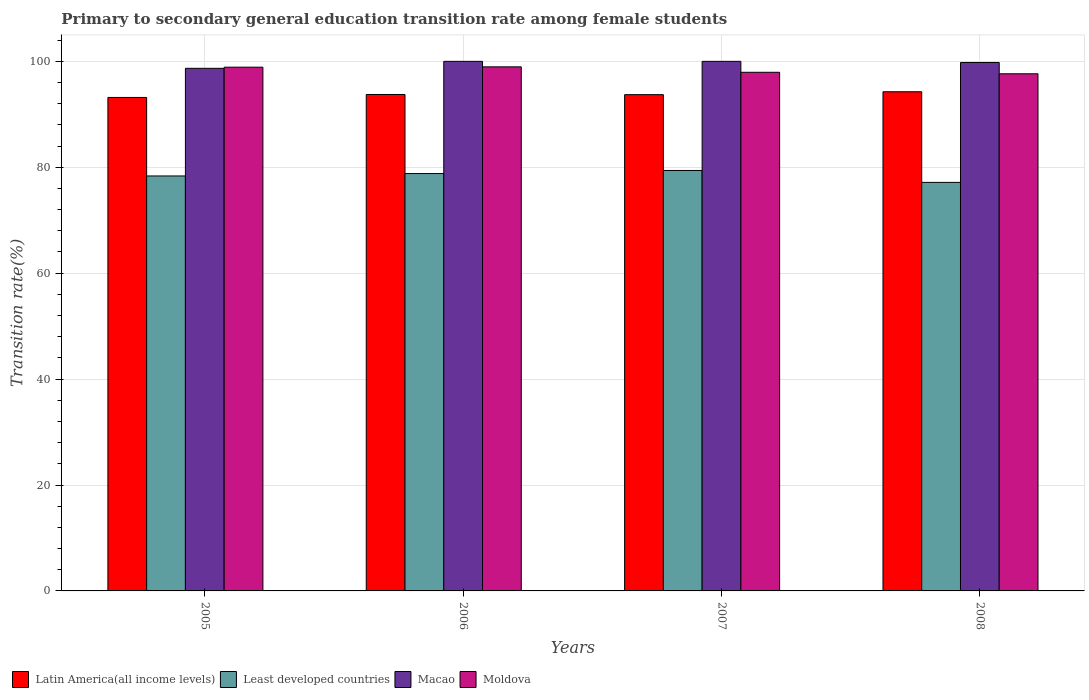Are the number of bars on each tick of the X-axis equal?
Offer a terse response. Yes. How many bars are there on the 1st tick from the left?
Provide a succinct answer. 4. How many bars are there on the 4th tick from the right?
Your answer should be very brief. 4. What is the transition rate in Latin America(all income levels) in 2005?
Provide a short and direct response. 93.18. Across all years, what is the minimum transition rate in Latin America(all income levels)?
Provide a short and direct response. 93.18. What is the total transition rate in Macao in the graph?
Your answer should be very brief. 398.47. What is the difference between the transition rate in Macao in 2006 and that in 2008?
Your response must be concise. 0.21. What is the difference between the transition rate in Least developed countries in 2007 and the transition rate in Moldova in 2008?
Offer a very short reply. -18.26. What is the average transition rate in Macao per year?
Your answer should be compact. 99.62. In the year 2006, what is the difference between the transition rate in Latin America(all income levels) and transition rate in Least developed countries?
Make the answer very short. 14.93. What is the ratio of the transition rate in Least developed countries in 2005 to that in 2007?
Give a very brief answer. 0.99. Is the difference between the transition rate in Latin America(all income levels) in 2005 and 2006 greater than the difference between the transition rate in Least developed countries in 2005 and 2006?
Make the answer very short. No. What is the difference between the highest and the second highest transition rate in Latin America(all income levels)?
Provide a short and direct response. 0.51. What is the difference between the highest and the lowest transition rate in Moldova?
Keep it short and to the point. 1.31. In how many years, is the transition rate in Latin America(all income levels) greater than the average transition rate in Latin America(all income levels) taken over all years?
Make the answer very short. 2. Is the sum of the transition rate in Moldova in 2005 and 2007 greater than the maximum transition rate in Macao across all years?
Provide a short and direct response. Yes. Is it the case that in every year, the sum of the transition rate in Latin America(all income levels) and transition rate in Least developed countries is greater than the sum of transition rate in Moldova and transition rate in Macao?
Offer a very short reply. Yes. What does the 1st bar from the left in 2006 represents?
Ensure brevity in your answer.  Latin America(all income levels). What does the 2nd bar from the right in 2005 represents?
Ensure brevity in your answer.  Macao. Are all the bars in the graph horizontal?
Your answer should be very brief. No. Are the values on the major ticks of Y-axis written in scientific E-notation?
Keep it short and to the point. No. Does the graph contain any zero values?
Keep it short and to the point. No. Does the graph contain grids?
Keep it short and to the point. Yes. What is the title of the graph?
Give a very brief answer. Primary to secondary general education transition rate among female students. What is the label or title of the X-axis?
Your response must be concise. Years. What is the label or title of the Y-axis?
Ensure brevity in your answer.  Transition rate(%). What is the Transition rate(%) of Latin America(all income levels) in 2005?
Your response must be concise. 93.18. What is the Transition rate(%) in Least developed countries in 2005?
Give a very brief answer. 78.36. What is the Transition rate(%) in Macao in 2005?
Provide a short and direct response. 98.68. What is the Transition rate(%) in Moldova in 2005?
Offer a very short reply. 98.9. What is the Transition rate(%) of Latin America(all income levels) in 2006?
Your answer should be compact. 93.74. What is the Transition rate(%) of Least developed countries in 2006?
Offer a terse response. 78.81. What is the Transition rate(%) of Moldova in 2006?
Offer a very short reply. 98.96. What is the Transition rate(%) of Latin America(all income levels) in 2007?
Your answer should be very brief. 93.71. What is the Transition rate(%) in Least developed countries in 2007?
Keep it short and to the point. 79.39. What is the Transition rate(%) in Macao in 2007?
Offer a very short reply. 100. What is the Transition rate(%) of Moldova in 2007?
Ensure brevity in your answer.  97.93. What is the Transition rate(%) of Latin America(all income levels) in 2008?
Keep it short and to the point. 94.26. What is the Transition rate(%) of Least developed countries in 2008?
Your answer should be compact. 77.15. What is the Transition rate(%) of Macao in 2008?
Offer a very short reply. 99.79. What is the Transition rate(%) of Moldova in 2008?
Offer a terse response. 97.65. Across all years, what is the maximum Transition rate(%) in Latin America(all income levels)?
Make the answer very short. 94.26. Across all years, what is the maximum Transition rate(%) of Least developed countries?
Your answer should be compact. 79.39. Across all years, what is the maximum Transition rate(%) in Moldova?
Make the answer very short. 98.96. Across all years, what is the minimum Transition rate(%) of Latin America(all income levels)?
Your answer should be very brief. 93.18. Across all years, what is the minimum Transition rate(%) of Least developed countries?
Offer a very short reply. 77.15. Across all years, what is the minimum Transition rate(%) of Macao?
Offer a very short reply. 98.68. Across all years, what is the minimum Transition rate(%) in Moldova?
Make the answer very short. 97.65. What is the total Transition rate(%) of Latin America(all income levels) in the graph?
Keep it short and to the point. 374.9. What is the total Transition rate(%) in Least developed countries in the graph?
Provide a short and direct response. 313.71. What is the total Transition rate(%) in Macao in the graph?
Offer a very short reply. 398.47. What is the total Transition rate(%) in Moldova in the graph?
Provide a succinct answer. 393.45. What is the difference between the Transition rate(%) in Latin America(all income levels) in 2005 and that in 2006?
Provide a succinct answer. -0.56. What is the difference between the Transition rate(%) in Least developed countries in 2005 and that in 2006?
Make the answer very short. -0.46. What is the difference between the Transition rate(%) of Macao in 2005 and that in 2006?
Your response must be concise. -1.32. What is the difference between the Transition rate(%) of Moldova in 2005 and that in 2006?
Give a very brief answer. -0.06. What is the difference between the Transition rate(%) in Latin America(all income levels) in 2005 and that in 2007?
Provide a short and direct response. -0.53. What is the difference between the Transition rate(%) of Least developed countries in 2005 and that in 2007?
Ensure brevity in your answer.  -1.04. What is the difference between the Transition rate(%) in Macao in 2005 and that in 2007?
Ensure brevity in your answer.  -1.32. What is the difference between the Transition rate(%) of Moldova in 2005 and that in 2007?
Provide a short and direct response. 0.96. What is the difference between the Transition rate(%) of Latin America(all income levels) in 2005 and that in 2008?
Make the answer very short. -1.07. What is the difference between the Transition rate(%) in Least developed countries in 2005 and that in 2008?
Provide a succinct answer. 1.21. What is the difference between the Transition rate(%) in Macao in 2005 and that in 2008?
Provide a short and direct response. -1.1. What is the difference between the Transition rate(%) of Moldova in 2005 and that in 2008?
Provide a short and direct response. 1.25. What is the difference between the Transition rate(%) in Latin America(all income levels) in 2006 and that in 2007?
Ensure brevity in your answer.  0.03. What is the difference between the Transition rate(%) of Least developed countries in 2006 and that in 2007?
Give a very brief answer. -0.58. What is the difference between the Transition rate(%) in Macao in 2006 and that in 2007?
Your response must be concise. 0. What is the difference between the Transition rate(%) in Latin America(all income levels) in 2006 and that in 2008?
Your answer should be compact. -0.51. What is the difference between the Transition rate(%) in Least developed countries in 2006 and that in 2008?
Make the answer very short. 1.67. What is the difference between the Transition rate(%) of Macao in 2006 and that in 2008?
Provide a short and direct response. 0.21. What is the difference between the Transition rate(%) in Moldova in 2006 and that in 2008?
Make the answer very short. 1.31. What is the difference between the Transition rate(%) in Latin America(all income levels) in 2007 and that in 2008?
Provide a short and direct response. -0.54. What is the difference between the Transition rate(%) of Least developed countries in 2007 and that in 2008?
Ensure brevity in your answer.  2.25. What is the difference between the Transition rate(%) of Macao in 2007 and that in 2008?
Your response must be concise. 0.21. What is the difference between the Transition rate(%) of Moldova in 2007 and that in 2008?
Your answer should be very brief. 0.28. What is the difference between the Transition rate(%) in Latin America(all income levels) in 2005 and the Transition rate(%) in Least developed countries in 2006?
Make the answer very short. 14.37. What is the difference between the Transition rate(%) of Latin America(all income levels) in 2005 and the Transition rate(%) of Macao in 2006?
Ensure brevity in your answer.  -6.82. What is the difference between the Transition rate(%) of Latin America(all income levels) in 2005 and the Transition rate(%) of Moldova in 2006?
Offer a terse response. -5.78. What is the difference between the Transition rate(%) in Least developed countries in 2005 and the Transition rate(%) in Macao in 2006?
Make the answer very short. -21.64. What is the difference between the Transition rate(%) in Least developed countries in 2005 and the Transition rate(%) in Moldova in 2006?
Your response must be concise. -20.6. What is the difference between the Transition rate(%) in Macao in 2005 and the Transition rate(%) in Moldova in 2006?
Provide a succinct answer. -0.28. What is the difference between the Transition rate(%) in Latin America(all income levels) in 2005 and the Transition rate(%) in Least developed countries in 2007?
Give a very brief answer. 13.79. What is the difference between the Transition rate(%) of Latin America(all income levels) in 2005 and the Transition rate(%) of Macao in 2007?
Ensure brevity in your answer.  -6.82. What is the difference between the Transition rate(%) in Latin America(all income levels) in 2005 and the Transition rate(%) in Moldova in 2007?
Ensure brevity in your answer.  -4.75. What is the difference between the Transition rate(%) in Least developed countries in 2005 and the Transition rate(%) in Macao in 2007?
Your answer should be very brief. -21.64. What is the difference between the Transition rate(%) of Least developed countries in 2005 and the Transition rate(%) of Moldova in 2007?
Ensure brevity in your answer.  -19.58. What is the difference between the Transition rate(%) of Macao in 2005 and the Transition rate(%) of Moldova in 2007?
Your response must be concise. 0.75. What is the difference between the Transition rate(%) in Latin America(all income levels) in 2005 and the Transition rate(%) in Least developed countries in 2008?
Ensure brevity in your answer.  16.04. What is the difference between the Transition rate(%) in Latin America(all income levels) in 2005 and the Transition rate(%) in Macao in 2008?
Your answer should be compact. -6.6. What is the difference between the Transition rate(%) in Latin America(all income levels) in 2005 and the Transition rate(%) in Moldova in 2008?
Keep it short and to the point. -4.47. What is the difference between the Transition rate(%) of Least developed countries in 2005 and the Transition rate(%) of Macao in 2008?
Give a very brief answer. -21.43. What is the difference between the Transition rate(%) of Least developed countries in 2005 and the Transition rate(%) of Moldova in 2008?
Ensure brevity in your answer.  -19.29. What is the difference between the Transition rate(%) of Macao in 2005 and the Transition rate(%) of Moldova in 2008?
Give a very brief answer. 1.03. What is the difference between the Transition rate(%) in Latin America(all income levels) in 2006 and the Transition rate(%) in Least developed countries in 2007?
Your answer should be compact. 14.35. What is the difference between the Transition rate(%) in Latin America(all income levels) in 2006 and the Transition rate(%) in Macao in 2007?
Offer a very short reply. -6.26. What is the difference between the Transition rate(%) in Latin America(all income levels) in 2006 and the Transition rate(%) in Moldova in 2007?
Ensure brevity in your answer.  -4.19. What is the difference between the Transition rate(%) of Least developed countries in 2006 and the Transition rate(%) of Macao in 2007?
Provide a succinct answer. -21.19. What is the difference between the Transition rate(%) of Least developed countries in 2006 and the Transition rate(%) of Moldova in 2007?
Provide a succinct answer. -19.12. What is the difference between the Transition rate(%) in Macao in 2006 and the Transition rate(%) in Moldova in 2007?
Your answer should be very brief. 2.07. What is the difference between the Transition rate(%) of Latin America(all income levels) in 2006 and the Transition rate(%) of Least developed countries in 2008?
Provide a succinct answer. 16.6. What is the difference between the Transition rate(%) in Latin America(all income levels) in 2006 and the Transition rate(%) in Macao in 2008?
Offer a terse response. -6.04. What is the difference between the Transition rate(%) in Latin America(all income levels) in 2006 and the Transition rate(%) in Moldova in 2008?
Make the answer very short. -3.91. What is the difference between the Transition rate(%) of Least developed countries in 2006 and the Transition rate(%) of Macao in 2008?
Offer a very short reply. -20.98. What is the difference between the Transition rate(%) of Least developed countries in 2006 and the Transition rate(%) of Moldova in 2008?
Your answer should be very brief. -18.84. What is the difference between the Transition rate(%) in Macao in 2006 and the Transition rate(%) in Moldova in 2008?
Offer a very short reply. 2.35. What is the difference between the Transition rate(%) in Latin America(all income levels) in 2007 and the Transition rate(%) in Least developed countries in 2008?
Ensure brevity in your answer.  16.57. What is the difference between the Transition rate(%) of Latin America(all income levels) in 2007 and the Transition rate(%) of Macao in 2008?
Your answer should be compact. -6.08. What is the difference between the Transition rate(%) of Latin America(all income levels) in 2007 and the Transition rate(%) of Moldova in 2008?
Your answer should be very brief. -3.94. What is the difference between the Transition rate(%) in Least developed countries in 2007 and the Transition rate(%) in Macao in 2008?
Your answer should be very brief. -20.39. What is the difference between the Transition rate(%) in Least developed countries in 2007 and the Transition rate(%) in Moldova in 2008?
Offer a terse response. -18.26. What is the difference between the Transition rate(%) in Macao in 2007 and the Transition rate(%) in Moldova in 2008?
Give a very brief answer. 2.35. What is the average Transition rate(%) in Latin America(all income levels) per year?
Offer a very short reply. 93.72. What is the average Transition rate(%) of Least developed countries per year?
Provide a short and direct response. 78.43. What is the average Transition rate(%) in Macao per year?
Keep it short and to the point. 99.62. What is the average Transition rate(%) in Moldova per year?
Provide a short and direct response. 98.36. In the year 2005, what is the difference between the Transition rate(%) of Latin America(all income levels) and Transition rate(%) of Least developed countries?
Offer a terse response. 14.83. In the year 2005, what is the difference between the Transition rate(%) of Latin America(all income levels) and Transition rate(%) of Macao?
Give a very brief answer. -5.5. In the year 2005, what is the difference between the Transition rate(%) in Latin America(all income levels) and Transition rate(%) in Moldova?
Provide a short and direct response. -5.72. In the year 2005, what is the difference between the Transition rate(%) of Least developed countries and Transition rate(%) of Macao?
Your answer should be compact. -20.33. In the year 2005, what is the difference between the Transition rate(%) in Least developed countries and Transition rate(%) in Moldova?
Offer a very short reply. -20.54. In the year 2005, what is the difference between the Transition rate(%) in Macao and Transition rate(%) in Moldova?
Provide a succinct answer. -0.21. In the year 2006, what is the difference between the Transition rate(%) in Latin America(all income levels) and Transition rate(%) in Least developed countries?
Your answer should be compact. 14.93. In the year 2006, what is the difference between the Transition rate(%) in Latin America(all income levels) and Transition rate(%) in Macao?
Ensure brevity in your answer.  -6.26. In the year 2006, what is the difference between the Transition rate(%) in Latin America(all income levels) and Transition rate(%) in Moldova?
Your answer should be very brief. -5.22. In the year 2006, what is the difference between the Transition rate(%) in Least developed countries and Transition rate(%) in Macao?
Make the answer very short. -21.19. In the year 2006, what is the difference between the Transition rate(%) in Least developed countries and Transition rate(%) in Moldova?
Give a very brief answer. -20.15. In the year 2006, what is the difference between the Transition rate(%) in Macao and Transition rate(%) in Moldova?
Provide a short and direct response. 1.04. In the year 2007, what is the difference between the Transition rate(%) of Latin America(all income levels) and Transition rate(%) of Least developed countries?
Give a very brief answer. 14.32. In the year 2007, what is the difference between the Transition rate(%) of Latin America(all income levels) and Transition rate(%) of Macao?
Offer a terse response. -6.29. In the year 2007, what is the difference between the Transition rate(%) of Latin America(all income levels) and Transition rate(%) of Moldova?
Ensure brevity in your answer.  -4.22. In the year 2007, what is the difference between the Transition rate(%) in Least developed countries and Transition rate(%) in Macao?
Offer a terse response. -20.61. In the year 2007, what is the difference between the Transition rate(%) of Least developed countries and Transition rate(%) of Moldova?
Make the answer very short. -18.54. In the year 2007, what is the difference between the Transition rate(%) in Macao and Transition rate(%) in Moldova?
Provide a short and direct response. 2.07. In the year 2008, what is the difference between the Transition rate(%) of Latin America(all income levels) and Transition rate(%) of Least developed countries?
Keep it short and to the point. 17.11. In the year 2008, what is the difference between the Transition rate(%) in Latin America(all income levels) and Transition rate(%) in Macao?
Keep it short and to the point. -5.53. In the year 2008, what is the difference between the Transition rate(%) of Latin America(all income levels) and Transition rate(%) of Moldova?
Keep it short and to the point. -3.39. In the year 2008, what is the difference between the Transition rate(%) in Least developed countries and Transition rate(%) in Macao?
Your response must be concise. -22.64. In the year 2008, what is the difference between the Transition rate(%) in Least developed countries and Transition rate(%) in Moldova?
Provide a succinct answer. -20.51. In the year 2008, what is the difference between the Transition rate(%) in Macao and Transition rate(%) in Moldova?
Provide a short and direct response. 2.14. What is the ratio of the Transition rate(%) in Least developed countries in 2005 to that in 2006?
Keep it short and to the point. 0.99. What is the ratio of the Transition rate(%) of Latin America(all income levels) in 2005 to that in 2007?
Offer a very short reply. 0.99. What is the ratio of the Transition rate(%) in Least developed countries in 2005 to that in 2007?
Offer a terse response. 0.99. What is the ratio of the Transition rate(%) of Moldova in 2005 to that in 2007?
Give a very brief answer. 1.01. What is the ratio of the Transition rate(%) of Least developed countries in 2005 to that in 2008?
Your response must be concise. 1.02. What is the ratio of the Transition rate(%) of Macao in 2005 to that in 2008?
Give a very brief answer. 0.99. What is the ratio of the Transition rate(%) in Moldova in 2005 to that in 2008?
Offer a terse response. 1.01. What is the ratio of the Transition rate(%) of Latin America(all income levels) in 2006 to that in 2007?
Give a very brief answer. 1. What is the ratio of the Transition rate(%) of Moldova in 2006 to that in 2007?
Give a very brief answer. 1.01. What is the ratio of the Transition rate(%) of Least developed countries in 2006 to that in 2008?
Your response must be concise. 1.02. What is the ratio of the Transition rate(%) of Moldova in 2006 to that in 2008?
Ensure brevity in your answer.  1.01. What is the ratio of the Transition rate(%) in Latin America(all income levels) in 2007 to that in 2008?
Ensure brevity in your answer.  0.99. What is the ratio of the Transition rate(%) in Least developed countries in 2007 to that in 2008?
Your answer should be very brief. 1.03. What is the ratio of the Transition rate(%) in Macao in 2007 to that in 2008?
Keep it short and to the point. 1. What is the difference between the highest and the second highest Transition rate(%) of Latin America(all income levels)?
Offer a terse response. 0.51. What is the difference between the highest and the second highest Transition rate(%) of Least developed countries?
Offer a very short reply. 0.58. What is the difference between the highest and the second highest Transition rate(%) in Macao?
Provide a succinct answer. 0. What is the difference between the highest and the second highest Transition rate(%) in Moldova?
Keep it short and to the point. 0.06. What is the difference between the highest and the lowest Transition rate(%) in Latin America(all income levels)?
Ensure brevity in your answer.  1.07. What is the difference between the highest and the lowest Transition rate(%) of Least developed countries?
Your response must be concise. 2.25. What is the difference between the highest and the lowest Transition rate(%) of Macao?
Give a very brief answer. 1.32. What is the difference between the highest and the lowest Transition rate(%) of Moldova?
Your answer should be compact. 1.31. 